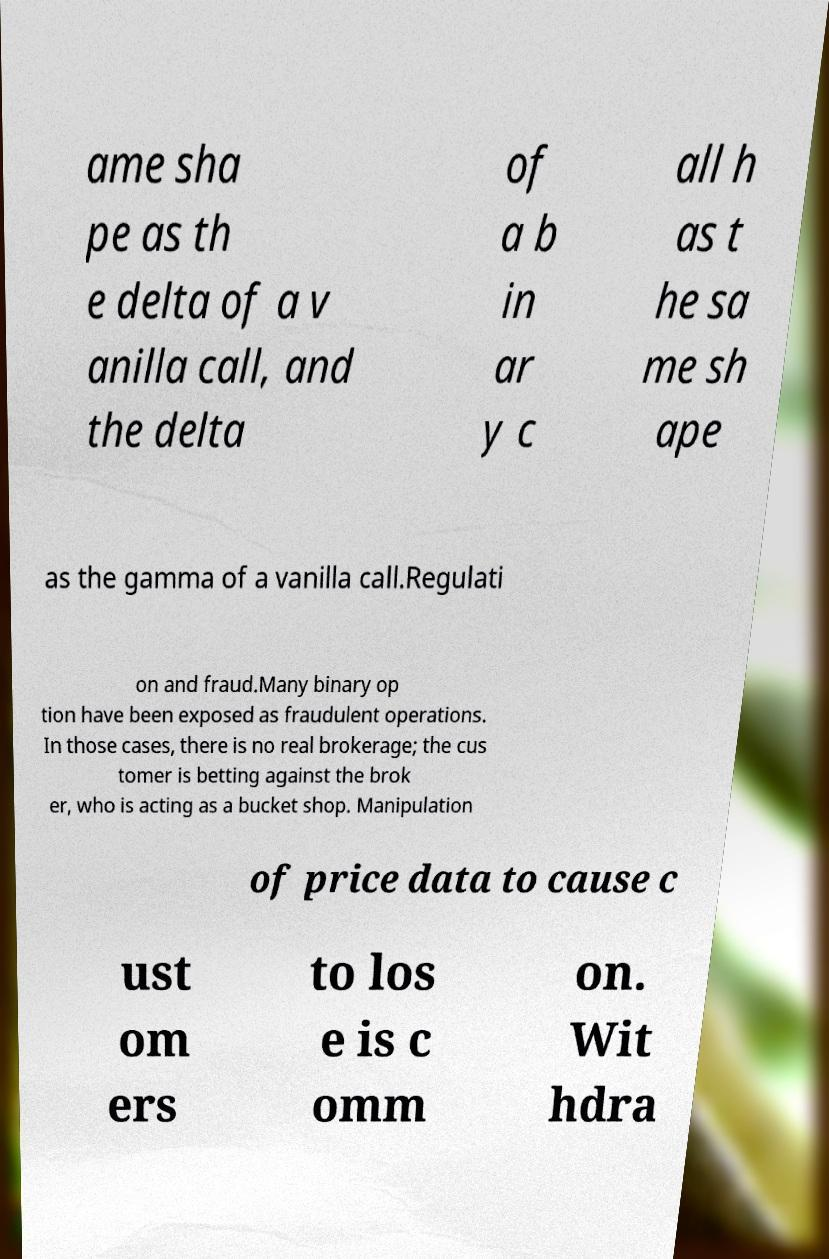Could you extract and type out the text from this image? ame sha pe as th e delta of a v anilla call, and the delta of a b in ar y c all h as t he sa me sh ape as the gamma of a vanilla call.Regulati on and fraud.Many binary op tion have been exposed as fraudulent operations. In those cases, there is no real brokerage; the cus tomer is betting against the brok er, who is acting as a bucket shop. Manipulation of price data to cause c ust om ers to los e is c omm on. Wit hdra 